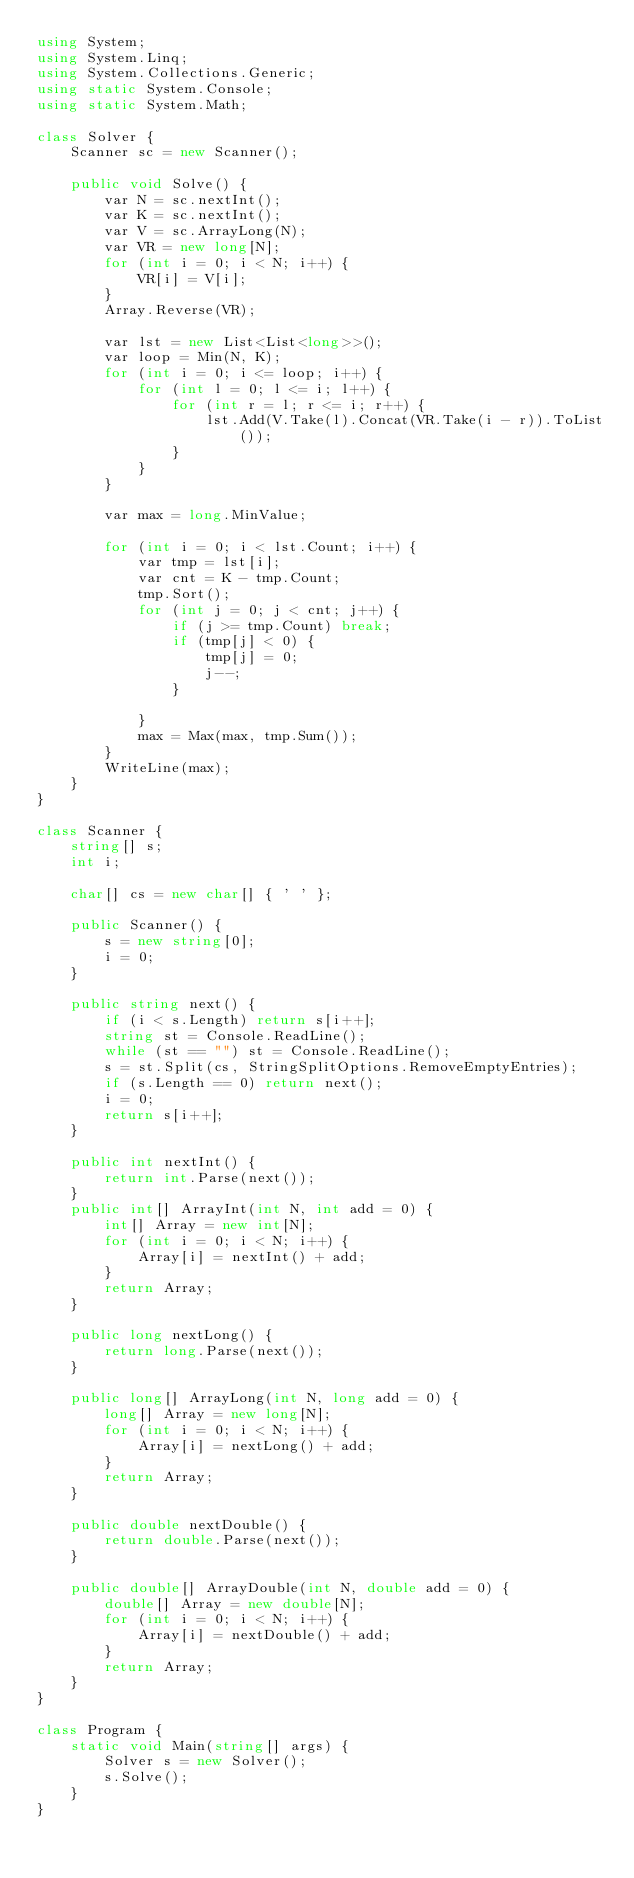Convert code to text. <code><loc_0><loc_0><loc_500><loc_500><_C#_>using System;
using System.Linq;
using System.Collections.Generic;
using static System.Console;
using static System.Math;

class Solver {
    Scanner sc = new Scanner();

    public void Solve() {
        var N = sc.nextInt();
        var K = sc.nextInt();
        var V = sc.ArrayLong(N);
        var VR = new long[N];
        for (int i = 0; i < N; i++) {
            VR[i] = V[i];
        }
        Array.Reverse(VR);

        var lst = new List<List<long>>();
        var loop = Min(N, K);
        for (int i = 0; i <= loop; i++) {
            for (int l = 0; l <= i; l++) {
                for (int r = l; r <= i; r++) {
                    lst.Add(V.Take(l).Concat(VR.Take(i - r)).ToList());
                }
            }
        }

        var max = long.MinValue;

        for (int i = 0; i < lst.Count; i++) {
            var tmp = lst[i];
            var cnt = K - tmp.Count;
            tmp.Sort();
            for (int j = 0; j < cnt; j++) {
                if (j >= tmp.Count) break;
                if (tmp[j] < 0) {
                    tmp[j] = 0;
                    j--;
                }

            }
            max = Max(max, tmp.Sum());
        }
        WriteLine(max);
    }
}

class Scanner {
    string[] s;
    int i;

    char[] cs = new char[] { ' ' };

    public Scanner() {
        s = new string[0];
        i = 0;
    }

    public string next() {
        if (i < s.Length) return s[i++];
        string st = Console.ReadLine();
        while (st == "") st = Console.ReadLine();
        s = st.Split(cs, StringSplitOptions.RemoveEmptyEntries);
        if (s.Length == 0) return next();
        i = 0;
        return s[i++];
    }

    public int nextInt() {
        return int.Parse(next());
    }
    public int[] ArrayInt(int N, int add = 0) {
        int[] Array = new int[N];
        for (int i = 0; i < N; i++) {
            Array[i] = nextInt() + add;
        }
        return Array;
    }

    public long nextLong() {
        return long.Parse(next());
    }

    public long[] ArrayLong(int N, long add = 0) {
        long[] Array = new long[N];
        for (int i = 0; i < N; i++) {
            Array[i] = nextLong() + add;
        }
        return Array;
    }

    public double nextDouble() {
        return double.Parse(next());
    }

    public double[] ArrayDouble(int N, double add = 0) {
        double[] Array = new double[N];
        for (int i = 0; i < N; i++) {
            Array[i] = nextDouble() + add;
        }
        return Array;
    }
}

class Program {
    static void Main(string[] args) {
        Solver s = new Solver();
        s.Solve();
    }
}
</code> 